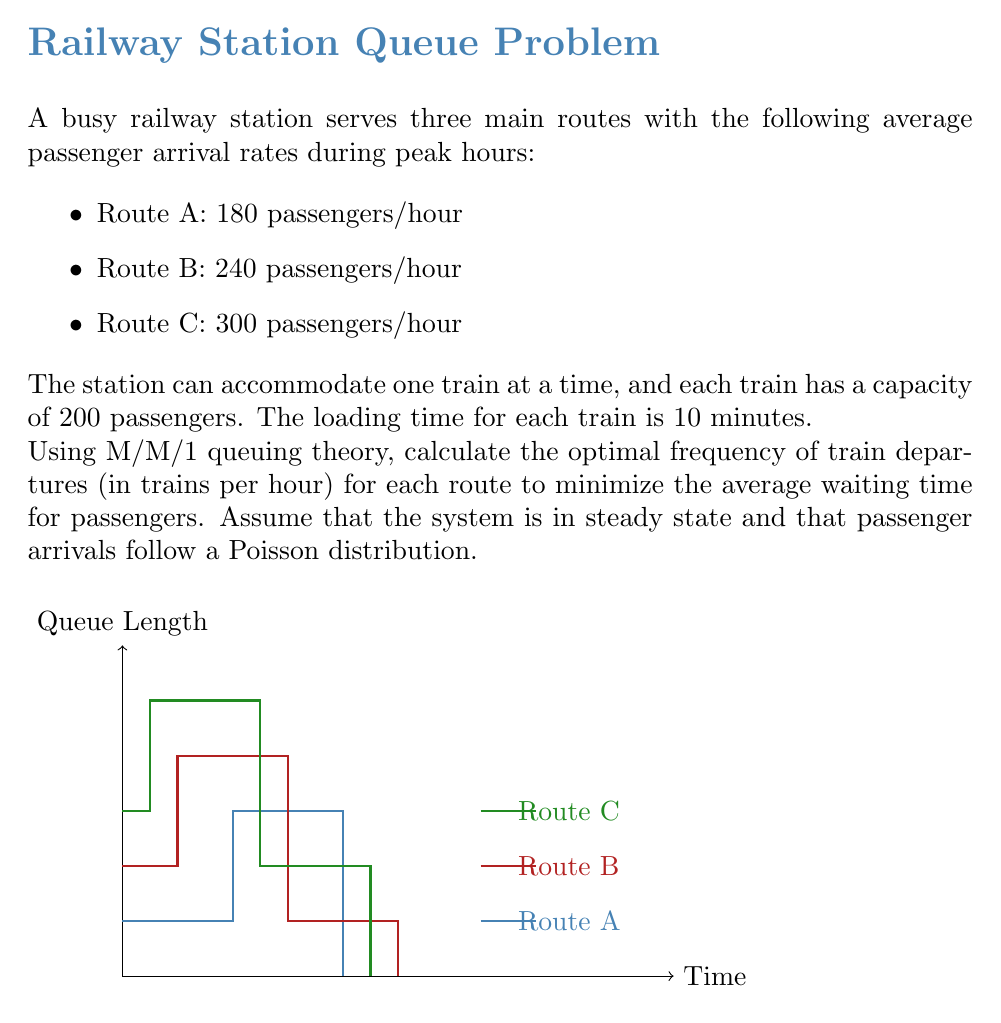Teach me how to tackle this problem. To solve this problem, we'll use the M/M/1 queuing model for each route. The optimal frequency of train departures will be when the service rate (μ) is slightly higher than the arrival rate (λ) to ensure stability and minimize waiting times.

Step 1: Calculate the minimum service rate for each route.
The minimum service rate should be higher than the arrival rate:

Route A: $\mu_A > \frac{180}{60} = 3$ passengers/minute
Route B: $\mu_B > \frac{240}{60} = 4$ passengers/minute
Route C: $\mu_C > \frac{300}{60} = 5$ passengers/minute

Step 2: Calculate the service time for each train.
Service time = Loading time + Travel time
We're given the loading time of 10 minutes, so:
Service time per train = 10 minutes

Step 3: Calculate the service rate (μ) in passengers per minute for each route.
$\mu = \frac{\text{Train capacity}}{\text{Service time}} = \frac{200}{10} = 20$ passengers/minute

Step 4: Calculate the optimal frequency of train departures for each route.
We want the service rate to be slightly higher than the arrival rate. Let's aim for a utilization factor (ρ) of about 0.9 for each route.

Route A: $\rho_A = \frac{\lambda_A}{\mu_A} = 0.9$
$\mu_A = \frac{\lambda_A}{0.9} = \frac{3}{0.9} = 3.33$ passengers/minute

Route B: $\rho_B = \frac{\lambda_B}{\mu_B} = 0.9$
$\mu_B = \frac{\lambda_B}{0.9} = \frac{4}{0.9} = 4.44$ passengers/minute

Route C: $\rho_C = \frac{\lambda_C}{\mu_C} = 0.9$
$\mu_C = \frac{\lambda_C}{0.9} = \frac{5}{0.9} = 5.56$ passengers/minute

Step 5: Convert the service rates to trains per hour.
Route A: $\frac{3.33}{20} \cdot 60 = 10$ trains/hour
Route B: $\frac{4.44}{20} \cdot 60 = 13.32$ trains/hour
Route C: $\frac{5.56}{20} \cdot 60 = 16.68$ trains/hour

Rounding to the nearest whole number:
Route A: 10 trains/hour
Route B: 13 trains/hour
Route C: 17 trains/hour

This schedule ensures that the waiting times are minimized while maintaining a stable system for each route.
Answer: Route A: 10 trains/hour, Route B: 13 trains/hour, Route C: 17 trains/hour 